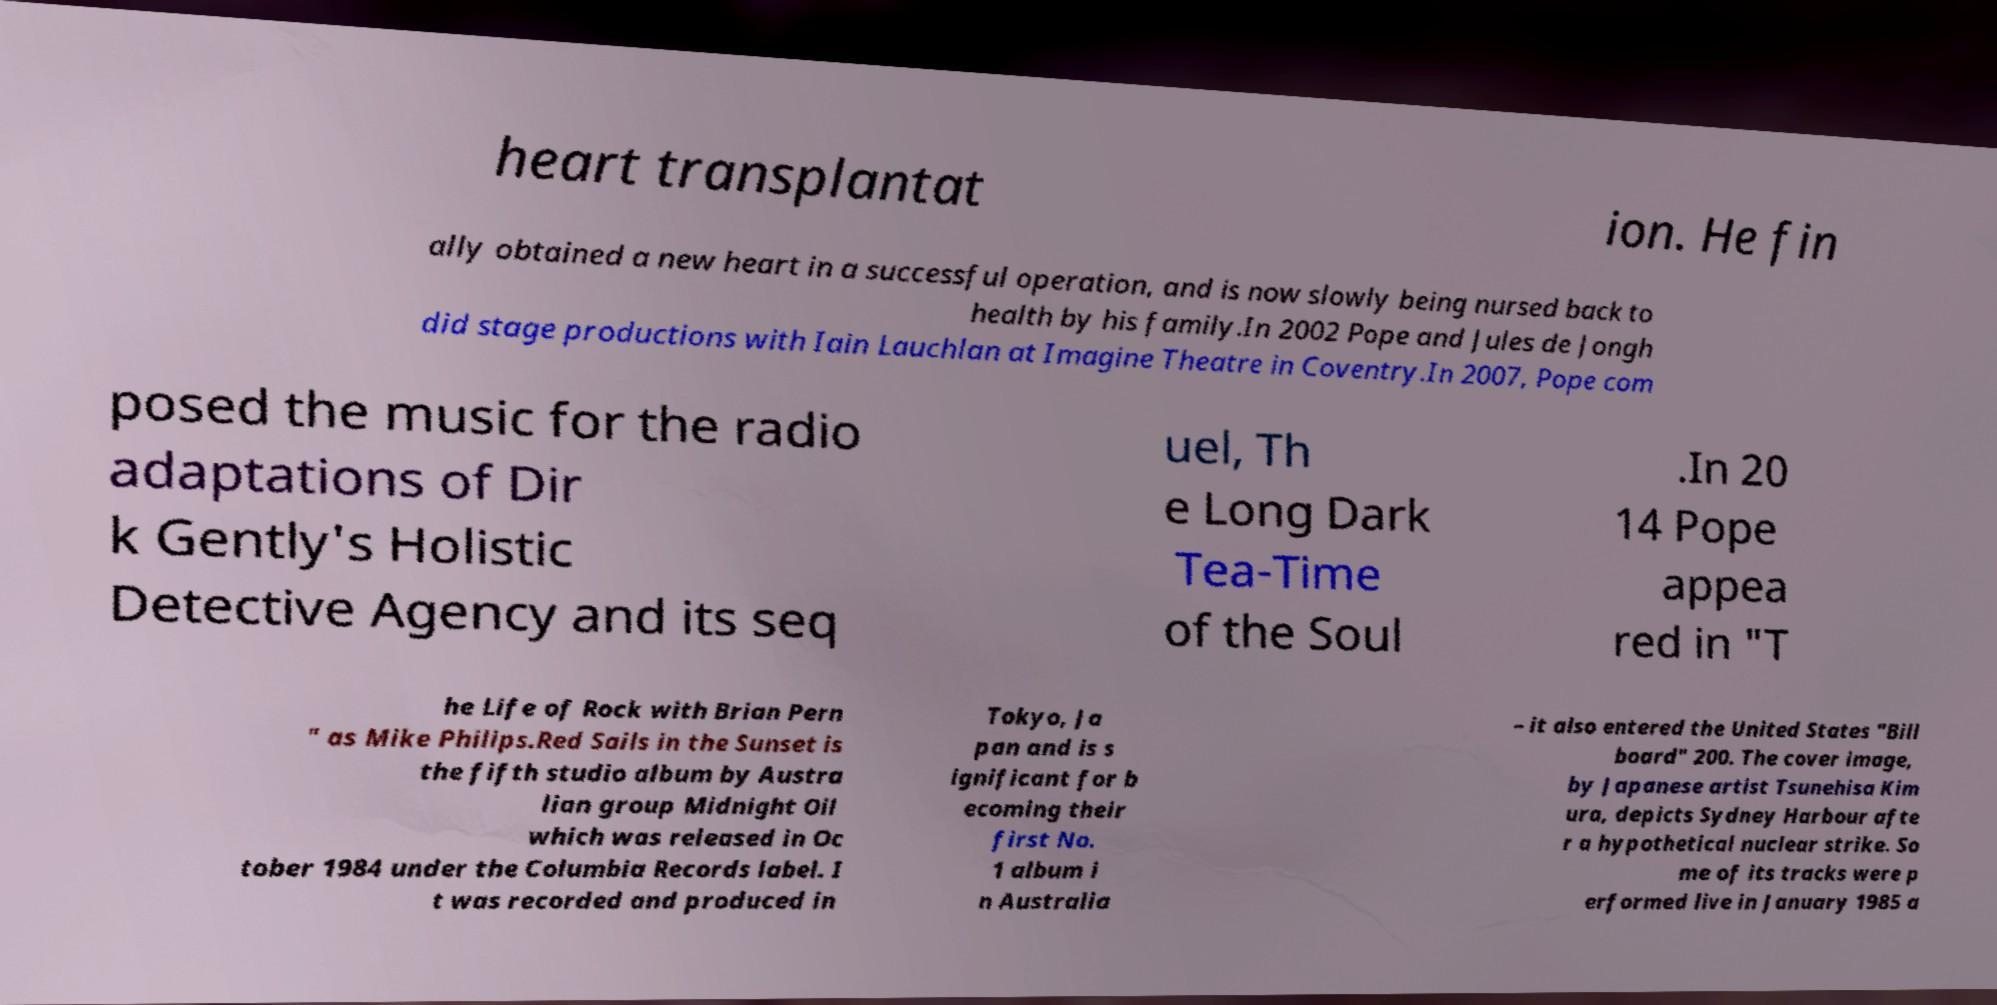Please read and relay the text visible in this image. What does it say? heart transplantat ion. He fin ally obtained a new heart in a successful operation, and is now slowly being nursed back to health by his family.In 2002 Pope and Jules de Jongh did stage productions with Iain Lauchlan at Imagine Theatre in Coventry.In 2007, Pope com posed the music for the radio adaptations of Dir k Gently's Holistic Detective Agency and its seq uel, Th e Long Dark Tea-Time of the Soul .In 20 14 Pope appea red in "T he Life of Rock with Brian Pern " as Mike Philips.Red Sails in the Sunset is the fifth studio album by Austra lian group Midnight Oil which was released in Oc tober 1984 under the Columbia Records label. I t was recorded and produced in Tokyo, Ja pan and is s ignificant for b ecoming their first No. 1 album i n Australia – it also entered the United States "Bill board" 200. The cover image, by Japanese artist Tsunehisa Kim ura, depicts Sydney Harbour afte r a hypothetical nuclear strike. So me of its tracks were p erformed live in January 1985 a 